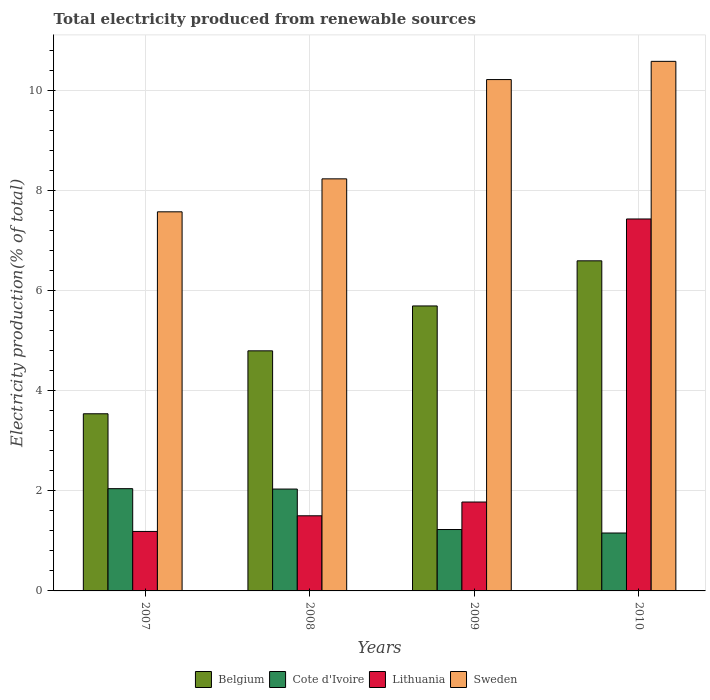How many different coloured bars are there?
Offer a terse response. 4. How many bars are there on the 1st tick from the left?
Your answer should be compact. 4. In how many cases, is the number of bars for a given year not equal to the number of legend labels?
Give a very brief answer. 0. What is the total electricity produced in Cote d'Ivoire in 2007?
Give a very brief answer. 2.04. Across all years, what is the maximum total electricity produced in Cote d'Ivoire?
Your response must be concise. 2.04. Across all years, what is the minimum total electricity produced in Lithuania?
Provide a short and direct response. 1.19. In which year was the total electricity produced in Cote d'Ivoire minimum?
Provide a succinct answer. 2010. What is the total total electricity produced in Lithuania in the graph?
Your answer should be very brief. 11.89. What is the difference between the total electricity produced in Cote d'Ivoire in 2007 and that in 2008?
Offer a very short reply. 0.01. What is the difference between the total electricity produced in Sweden in 2007 and the total electricity produced in Cote d'Ivoire in 2009?
Make the answer very short. 6.35. What is the average total electricity produced in Belgium per year?
Offer a very short reply. 5.15. In the year 2010, what is the difference between the total electricity produced in Cote d'Ivoire and total electricity produced in Sweden?
Keep it short and to the point. -9.42. In how many years, is the total electricity produced in Belgium greater than 2 %?
Your answer should be compact. 4. What is the ratio of the total electricity produced in Belgium in 2008 to that in 2010?
Give a very brief answer. 0.73. Is the total electricity produced in Lithuania in 2007 less than that in 2010?
Your response must be concise. Yes. Is the difference between the total electricity produced in Cote d'Ivoire in 2008 and 2010 greater than the difference between the total electricity produced in Sweden in 2008 and 2010?
Your answer should be very brief. Yes. What is the difference between the highest and the second highest total electricity produced in Lithuania?
Your response must be concise. 5.65. What is the difference between the highest and the lowest total electricity produced in Lithuania?
Your answer should be compact. 6.24. What does the 3rd bar from the left in 2007 represents?
Provide a short and direct response. Lithuania. What does the 2nd bar from the right in 2008 represents?
Your response must be concise. Lithuania. How many bars are there?
Offer a terse response. 16. Are all the bars in the graph horizontal?
Your answer should be compact. No. How many years are there in the graph?
Keep it short and to the point. 4. What is the difference between two consecutive major ticks on the Y-axis?
Your answer should be compact. 2. Are the values on the major ticks of Y-axis written in scientific E-notation?
Your answer should be very brief. No. Does the graph contain any zero values?
Give a very brief answer. No. Where does the legend appear in the graph?
Provide a succinct answer. Bottom center. What is the title of the graph?
Your answer should be very brief. Total electricity produced from renewable sources. What is the label or title of the X-axis?
Give a very brief answer. Years. What is the Electricity production(% of total) in Belgium in 2007?
Ensure brevity in your answer.  3.54. What is the Electricity production(% of total) in Cote d'Ivoire in 2007?
Make the answer very short. 2.04. What is the Electricity production(% of total) of Lithuania in 2007?
Offer a very short reply. 1.19. What is the Electricity production(% of total) of Sweden in 2007?
Your answer should be very brief. 7.57. What is the Electricity production(% of total) in Belgium in 2008?
Ensure brevity in your answer.  4.8. What is the Electricity production(% of total) in Cote d'Ivoire in 2008?
Provide a succinct answer. 2.03. What is the Electricity production(% of total) in Lithuania in 2008?
Your answer should be compact. 1.5. What is the Electricity production(% of total) in Sweden in 2008?
Your answer should be compact. 8.23. What is the Electricity production(% of total) of Belgium in 2009?
Your answer should be compact. 5.69. What is the Electricity production(% of total) in Cote d'Ivoire in 2009?
Your answer should be compact. 1.23. What is the Electricity production(% of total) in Lithuania in 2009?
Your answer should be compact. 1.78. What is the Electricity production(% of total) in Sweden in 2009?
Offer a very short reply. 10.21. What is the Electricity production(% of total) in Belgium in 2010?
Provide a succinct answer. 6.59. What is the Electricity production(% of total) of Cote d'Ivoire in 2010?
Your answer should be very brief. 1.16. What is the Electricity production(% of total) of Lithuania in 2010?
Your answer should be very brief. 7.43. What is the Electricity production(% of total) of Sweden in 2010?
Ensure brevity in your answer.  10.58. Across all years, what is the maximum Electricity production(% of total) in Belgium?
Offer a very short reply. 6.59. Across all years, what is the maximum Electricity production(% of total) in Cote d'Ivoire?
Offer a very short reply. 2.04. Across all years, what is the maximum Electricity production(% of total) in Lithuania?
Provide a succinct answer. 7.43. Across all years, what is the maximum Electricity production(% of total) in Sweden?
Ensure brevity in your answer.  10.58. Across all years, what is the minimum Electricity production(% of total) of Belgium?
Ensure brevity in your answer.  3.54. Across all years, what is the minimum Electricity production(% of total) of Cote d'Ivoire?
Your response must be concise. 1.16. Across all years, what is the minimum Electricity production(% of total) in Lithuania?
Keep it short and to the point. 1.19. Across all years, what is the minimum Electricity production(% of total) of Sweden?
Your response must be concise. 7.57. What is the total Electricity production(% of total) of Belgium in the graph?
Keep it short and to the point. 20.62. What is the total Electricity production(% of total) in Cote d'Ivoire in the graph?
Your answer should be compact. 6.46. What is the total Electricity production(% of total) in Lithuania in the graph?
Offer a terse response. 11.89. What is the total Electricity production(% of total) of Sweden in the graph?
Provide a succinct answer. 36.59. What is the difference between the Electricity production(% of total) in Belgium in 2007 and that in 2008?
Your answer should be very brief. -1.26. What is the difference between the Electricity production(% of total) in Cote d'Ivoire in 2007 and that in 2008?
Your answer should be very brief. 0.01. What is the difference between the Electricity production(% of total) of Lithuania in 2007 and that in 2008?
Your answer should be compact. -0.31. What is the difference between the Electricity production(% of total) of Sweden in 2007 and that in 2008?
Offer a very short reply. -0.66. What is the difference between the Electricity production(% of total) of Belgium in 2007 and that in 2009?
Provide a short and direct response. -2.15. What is the difference between the Electricity production(% of total) in Cote d'Ivoire in 2007 and that in 2009?
Your answer should be compact. 0.82. What is the difference between the Electricity production(% of total) of Lithuania in 2007 and that in 2009?
Offer a terse response. -0.59. What is the difference between the Electricity production(% of total) in Sweden in 2007 and that in 2009?
Make the answer very short. -2.64. What is the difference between the Electricity production(% of total) in Belgium in 2007 and that in 2010?
Your answer should be compact. -3.05. What is the difference between the Electricity production(% of total) of Cote d'Ivoire in 2007 and that in 2010?
Your answer should be compact. 0.89. What is the difference between the Electricity production(% of total) in Lithuania in 2007 and that in 2010?
Keep it short and to the point. -6.24. What is the difference between the Electricity production(% of total) in Sweden in 2007 and that in 2010?
Provide a succinct answer. -3.01. What is the difference between the Electricity production(% of total) of Belgium in 2008 and that in 2009?
Provide a short and direct response. -0.9. What is the difference between the Electricity production(% of total) in Cote d'Ivoire in 2008 and that in 2009?
Keep it short and to the point. 0.81. What is the difference between the Electricity production(% of total) in Lithuania in 2008 and that in 2009?
Give a very brief answer. -0.27. What is the difference between the Electricity production(% of total) in Sweden in 2008 and that in 2009?
Provide a short and direct response. -1.98. What is the difference between the Electricity production(% of total) in Belgium in 2008 and that in 2010?
Give a very brief answer. -1.8. What is the difference between the Electricity production(% of total) of Cote d'Ivoire in 2008 and that in 2010?
Keep it short and to the point. 0.88. What is the difference between the Electricity production(% of total) in Lithuania in 2008 and that in 2010?
Provide a short and direct response. -5.93. What is the difference between the Electricity production(% of total) in Sweden in 2008 and that in 2010?
Provide a short and direct response. -2.35. What is the difference between the Electricity production(% of total) of Belgium in 2009 and that in 2010?
Give a very brief answer. -0.9. What is the difference between the Electricity production(% of total) in Cote d'Ivoire in 2009 and that in 2010?
Keep it short and to the point. 0.07. What is the difference between the Electricity production(% of total) of Lithuania in 2009 and that in 2010?
Your answer should be very brief. -5.65. What is the difference between the Electricity production(% of total) of Sweden in 2009 and that in 2010?
Offer a very short reply. -0.36. What is the difference between the Electricity production(% of total) of Belgium in 2007 and the Electricity production(% of total) of Cote d'Ivoire in 2008?
Your response must be concise. 1.5. What is the difference between the Electricity production(% of total) in Belgium in 2007 and the Electricity production(% of total) in Lithuania in 2008?
Offer a very short reply. 2.04. What is the difference between the Electricity production(% of total) of Belgium in 2007 and the Electricity production(% of total) of Sweden in 2008?
Provide a succinct answer. -4.69. What is the difference between the Electricity production(% of total) of Cote d'Ivoire in 2007 and the Electricity production(% of total) of Lithuania in 2008?
Provide a short and direct response. 0.54. What is the difference between the Electricity production(% of total) of Cote d'Ivoire in 2007 and the Electricity production(% of total) of Sweden in 2008?
Provide a short and direct response. -6.19. What is the difference between the Electricity production(% of total) in Lithuania in 2007 and the Electricity production(% of total) in Sweden in 2008?
Make the answer very short. -7.04. What is the difference between the Electricity production(% of total) of Belgium in 2007 and the Electricity production(% of total) of Cote d'Ivoire in 2009?
Ensure brevity in your answer.  2.31. What is the difference between the Electricity production(% of total) in Belgium in 2007 and the Electricity production(% of total) in Lithuania in 2009?
Provide a short and direct response. 1.76. What is the difference between the Electricity production(% of total) in Belgium in 2007 and the Electricity production(% of total) in Sweden in 2009?
Provide a short and direct response. -6.68. What is the difference between the Electricity production(% of total) of Cote d'Ivoire in 2007 and the Electricity production(% of total) of Lithuania in 2009?
Your answer should be compact. 0.27. What is the difference between the Electricity production(% of total) in Cote d'Ivoire in 2007 and the Electricity production(% of total) in Sweden in 2009?
Ensure brevity in your answer.  -8.17. What is the difference between the Electricity production(% of total) in Lithuania in 2007 and the Electricity production(% of total) in Sweden in 2009?
Provide a succinct answer. -9.03. What is the difference between the Electricity production(% of total) in Belgium in 2007 and the Electricity production(% of total) in Cote d'Ivoire in 2010?
Offer a very short reply. 2.38. What is the difference between the Electricity production(% of total) of Belgium in 2007 and the Electricity production(% of total) of Lithuania in 2010?
Your answer should be compact. -3.89. What is the difference between the Electricity production(% of total) of Belgium in 2007 and the Electricity production(% of total) of Sweden in 2010?
Your answer should be very brief. -7.04. What is the difference between the Electricity production(% of total) of Cote d'Ivoire in 2007 and the Electricity production(% of total) of Lithuania in 2010?
Provide a short and direct response. -5.39. What is the difference between the Electricity production(% of total) in Cote d'Ivoire in 2007 and the Electricity production(% of total) in Sweden in 2010?
Your response must be concise. -8.54. What is the difference between the Electricity production(% of total) in Lithuania in 2007 and the Electricity production(% of total) in Sweden in 2010?
Your answer should be compact. -9.39. What is the difference between the Electricity production(% of total) in Belgium in 2008 and the Electricity production(% of total) in Cote d'Ivoire in 2009?
Provide a succinct answer. 3.57. What is the difference between the Electricity production(% of total) of Belgium in 2008 and the Electricity production(% of total) of Lithuania in 2009?
Your response must be concise. 3.02. What is the difference between the Electricity production(% of total) of Belgium in 2008 and the Electricity production(% of total) of Sweden in 2009?
Your answer should be very brief. -5.42. What is the difference between the Electricity production(% of total) of Cote d'Ivoire in 2008 and the Electricity production(% of total) of Lithuania in 2009?
Your response must be concise. 0.26. What is the difference between the Electricity production(% of total) in Cote d'Ivoire in 2008 and the Electricity production(% of total) in Sweden in 2009?
Offer a terse response. -8.18. What is the difference between the Electricity production(% of total) in Lithuania in 2008 and the Electricity production(% of total) in Sweden in 2009?
Offer a terse response. -8.71. What is the difference between the Electricity production(% of total) of Belgium in 2008 and the Electricity production(% of total) of Cote d'Ivoire in 2010?
Your answer should be very brief. 3.64. What is the difference between the Electricity production(% of total) in Belgium in 2008 and the Electricity production(% of total) in Lithuania in 2010?
Ensure brevity in your answer.  -2.63. What is the difference between the Electricity production(% of total) in Belgium in 2008 and the Electricity production(% of total) in Sweden in 2010?
Give a very brief answer. -5.78. What is the difference between the Electricity production(% of total) of Cote d'Ivoire in 2008 and the Electricity production(% of total) of Lithuania in 2010?
Keep it short and to the point. -5.39. What is the difference between the Electricity production(% of total) in Cote d'Ivoire in 2008 and the Electricity production(% of total) in Sweden in 2010?
Your response must be concise. -8.54. What is the difference between the Electricity production(% of total) in Lithuania in 2008 and the Electricity production(% of total) in Sweden in 2010?
Your answer should be very brief. -9.08. What is the difference between the Electricity production(% of total) in Belgium in 2009 and the Electricity production(% of total) in Cote d'Ivoire in 2010?
Provide a succinct answer. 4.54. What is the difference between the Electricity production(% of total) of Belgium in 2009 and the Electricity production(% of total) of Lithuania in 2010?
Provide a succinct answer. -1.74. What is the difference between the Electricity production(% of total) in Belgium in 2009 and the Electricity production(% of total) in Sweden in 2010?
Make the answer very short. -4.89. What is the difference between the Electricity production(% of total) of Cote d'Ivoire in 2009 and the Electricity production(% of total) of Lithuania in 2010?
Provide a succinct answer. -6.2. What is the difference between the Electricity production(% of total) in Cote d'Ivoire in 2009 and the Electricity production(% of total) in Sweden in 2010?
Your response must be concise. -9.35. What is the difference between the Electricity production(% of total) in Lithuania in 2009 and the Electricity production(% of total) in Sweden in 2010?
Give a very brief answer. -8.8. What is the average Electricity production(% of total) in Belgium per year?
Offer a very short reply. 5.15. What is the average Electricity production(% of total) in Cote d'Ivoire per year?
Your answer should be very brief. 1.61. What is the average Electricity production(% of total) in Lithuania per year?
Your answer should be very brief. 2.97. What is the average Electricity production(% of total) in Sweden per year?
Offer a terse response. 9.15. In the year 2007, what is the difference between the Electricity production(% of total) in Belgium and Electricity production(% of total) in Cote d'Ivoire?
Ensure brevity in your answer.  1.5. In the year 2007, what is the difference between the Electricity production(% of total) in Belgium and Electricity production(% of total) in Lithuania?
Offer a very short reply. 2.35. In the year 2007, what is the difference between the Electricity production(% of total) of Belgium and Electricity production(% of total) of Sweden?
Keep it short and to the point. -4.03. In the year 2007, what is the difference between the Electricity production(% of total) in Cote d'Ivoire and Electricity production(% of total) in Lithuania?
Your response must be concise. 0.85. In the year 2007, what is the difference between the Electricity production(% of total) in Cote d'Ivoire and Electricity production(% of total) in Sweden?
Offer a terse response. -5.53. In the year 2007, what is the difference between the Electricity production(% of total) in Lithuania and Electricity production(% of total) in Sweden?
Give a very brief answer. -6.38. In the year 2008, what is the difference between the Electricity production(% of total) in Belgium and Electricity production(% of total) in Cote d'Ivoire?
Provide a succinct answer. 2.76. In the year 2008, what is the difference between the Electricity production(% of total) in Belgium and Electricity production(% of total) in Lithuania?
Ensure brevity in your answer.  3.29. In the year 2008, what is the difference between the Electricity production(% of total) in Belgium and Electricity production(% of total) in Sweden?
Your answer should be very brief. -3.44. In the year 2008, what is the difference between the Electricity production(% of total) of Cote d'Ivoire and Electricity production(% of total) of Lithuania?
Keep it short and to the point. 0.53. In the year 2008, what is the difference between the Electricity production(% of total) of Cote d'Ivoire and Electricity production(% of total) of Sweden?
Make the answer very short. -6.2. In the year 2008, what is the difference between the Electricity production(% of total) of Lithuania and Electricity production(% of total) of Sweden?
Your answer should be compact. -6.73. In the year 2009, what is the difference between the Electricity production(% of total) in Belgium and Electricity production(% of total) in Cote d'Ivoire?
Give a very brief answer. 4.47. In the year 2009, what is the difference between the Electricity production(% of total) in Belgium and Electricity production(% of total) in Lithuania?
Offer a terse response. 3.92. In the year 2009, what is the difference between the Electricity production(% of total) of Belgium and Electricity production(% of total) of Sweden?
Your answer should be compact. -4.52. In the year 2009, what is the difference between the Electricity production(% of total) in Cote d'Ivoire and Electricity production(% of total) in Lithuania?
Your answer should be compact. -0.55. In the year 2009, what is the difference between the Electricity production(% of total) in Cote d'Ivoire and Electricity production(% of total) in Sweden?
Your answer should be compact. -8.99. In the year 2009, what is the difference between the Electricity production(% of total) in Lithuania and Electricity production(% of total) in Sweden?
Your answer should be compact. -8.44. In the year 2010, what is the difference between the Electricity production(% of total) of Belgium and Electricity production(% of total) of Cote d'Ivoire?
Your response must be concise. 5.44. In the year 2010, what is the difference between the Electricity production(% of total) of Belgium and Electricity production(% of total) of Lithuania?
Give a very brief answer. -0.84. In the year 2010, what is the difference between the Electricity production(% of total) of Belgium and Electricity production(% of total) of Sweden?
Give a very brief answer. -3.98. In the year 2010, what is the difference between the Electricity production(% of total) in Cote d'Ivoire and Electricity production(% of total) in Lithuania?
Offer a terse response. -6.27. In the year 2010, what is the difference between the Electricity production(% of total) in Cote d'Ivoire and Electricity production(% of total) in Sweden?
Your answer should be compact. -9.42. In the year 2010, what is the difference between the Electricity production(% of total) in Lithuania and Electricity production(% of total) in Sweden?
Offer a very short reply. -3.15. What is the ratio of the Electricity production(% of total) in Belgium in 2007 to that in 2008?
Provide a short and direct response. 0.74. What is the ratio of the Electricity production(% of total) of Lithuania in 2007 to that in 2008?
Keep it short and to the point. 0.79. What is the ratio of the Electricity production(% of total) in Belgium in 2007 to that in 2009?
Make the answer very short. 0.62. What is the ratio of the Electricity production(% of total) in Cote d'Ivoire in 2007 to that in 2009?
Your response must be concise. 1.67. What is the ratio of the Electricity production(% of total) of Lithuania in 2007 to that in 2009?
Your answer should be compact. 0.67. What is the ratio of the Electricity production(% of total) of Sweden in 2007 to that in 2009?
Your response must be concise. 0.74. What is the ratio of the Electricity production(% of total) in Belgium in 2007 to that in 2010?
Your response must be concise. 0.54. What is the ratio of the Electricity production(% of total) in Cote d'Ivoire in 2007 to that in 2010?
Your answer should be very brief. 1.77. What is the ratio of the Electricity production(% of total) of Lithuania in 2007 to that in 2010?
Provide a succinct answer. 0.16. What is the ratio of the Electricity production(% of total) of Sweden in 2007 to that in 2010?
Provide a succinct answer. 0.72. What is the ratio of the Electricity production(% of total) in Belgium in 2008 to that in 2009?
Your answer should be compact. 0.84. What is the ratio of the Electricity production(% of total) of Cote d'Ivoire in 2008 to that in 2009?
Give a very brief answer. 1.66. What is the ratio of the Electricity production(% of total) of Lithuania in 2008 to that in 2009?
Make the answer very short. 0.85. What is the ratio of the Electricity production(% of total) in Sweden in 2008 to that in 2009?
Offer a terse response. 0.81. What is the ratio of the Electricity production(% of total) in Belgium in 2008 to that in 2010?
Offer a terse response. 0.73. What is the ratio of the Electricity production(% of total) of Cote d'Ivoire in 2008 to that in 2010?
Give a very brief answer. 1.76. What is the ratio of the Electricity production(% of total) of Lithuania in 2008 to that in 2010?
Provide a short and direct response. 0.2. What is the ratio of the Electricity production(% of total) in Sweden in 2008 to that in 2010?
Your answer should be compact. 0.78. What is the ratio of the Electricity production(% of total) of Belgium in 2009 to that in 2010?
Your response must be concise. 0.86. What is the ratio of the Electricity production(% of total) of Cote d'Ivoire in 2009 to that in 2010?
Offer a very short reply. 1.06. What is the ratio of the Electricity production(% of total) of Lithuania in 2009 to that in 2010?
Ensure brevity in your answer.  0.24. What is the ratio of the Electricity production(% of total) in Sweden in 2009 to that in 2010?
Keep it short and to the point. 0.97. What is the difference between the highest and the second highest Electricity production(% of total) in Belgium?
Your response must be concise. 0.9. What is the difference between the highest and the second highest Electricity production(% of total) in Cote d'Ivoire?
Provide a short and direct response. 0.01. What is the difference between the highest and the second highest Electricity production(% of total) in Lithuania?
Give a very brief answer. 5.65. What is the difference between the highest and the second highest Electricity production(% of total) of Sweden?
Offer a terse response. 0.36. What is the difference between the highest and the lowest Electricity production(% of total) in Belgium?
Ensure brevity in your answer.  3.05. What is the difference between the highest and the lowest Electricity production(% of total) of Cote d'Ivoire?
Your response must be concise. 0.89. What is the difference between the highest and the lowest Electricity production(% of total) of Lithuania?
Make the answer very short. 6.24. What is the difference between the highest and the lowest Electricity production(% of total) of Sweden?
Offer a very short reply. 3.01. 